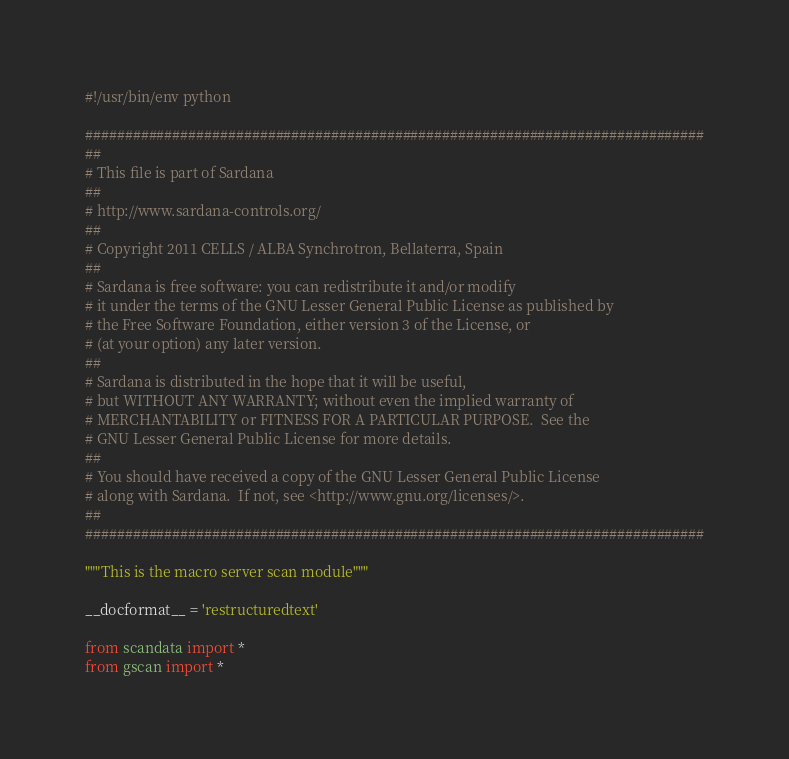<code> <loc_0><loc_0><loc_500><loc_500><_Python_>#!/usr/bin/env python

##############################################################################
##
# This file is part of Sardana
##
# http://www.sardana-controls.org/
##
# Copyright 2011 CELLS / ALBA Synchrotron, Bellaterra, Spain
##
# Sardana is free software: you can redistribute it and/or modify
# it under the terms of the GNU Lesser General Public License as published by
# the Free Software Foundation, either version 3 of the License, or
# (at your option) any later version.
##
# Sardana is distributed in the hope that it will be useful,
# but WITHOUT ANY WARRANTY; without even the implied warranty of
# MERCHANTABILITY or FITNESS FOR A PARTICULAR PURPOSE.  See the
# GNU Lesser General Public License for more details.
##
# You should have received a copy of the GNU Lesser General Public License
# along with Sardana.  If not, see <http://www.gnu.org/licenses/>.
##
##############################################################################

"""This is the macro server scan module"""

__docformat__ = 'restructuredtext'

from scandata import *
from gscan import *
</code> 